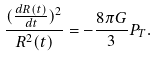<formula> <loc_0><loc_0><loc_500><loc_500>\frac { ( \frac { d R ( t ) } { d t } ) ^ { 2 } } { R ^ { 2 } ( t ) } = - { \frac { 8 \pi G } 3 } P _ { T } .</formula> 